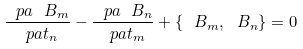<formula> <loc_0><loc_0><loc_500><loc_500>\frac { \ p a \ B _ { m } } { \ p a t _ { n } } - \frac { \ p a \ B _ { n } } { \ p a t _ { m } } + \{ \ B _ { m } , \ B _ { n } \} = 0</formula> 